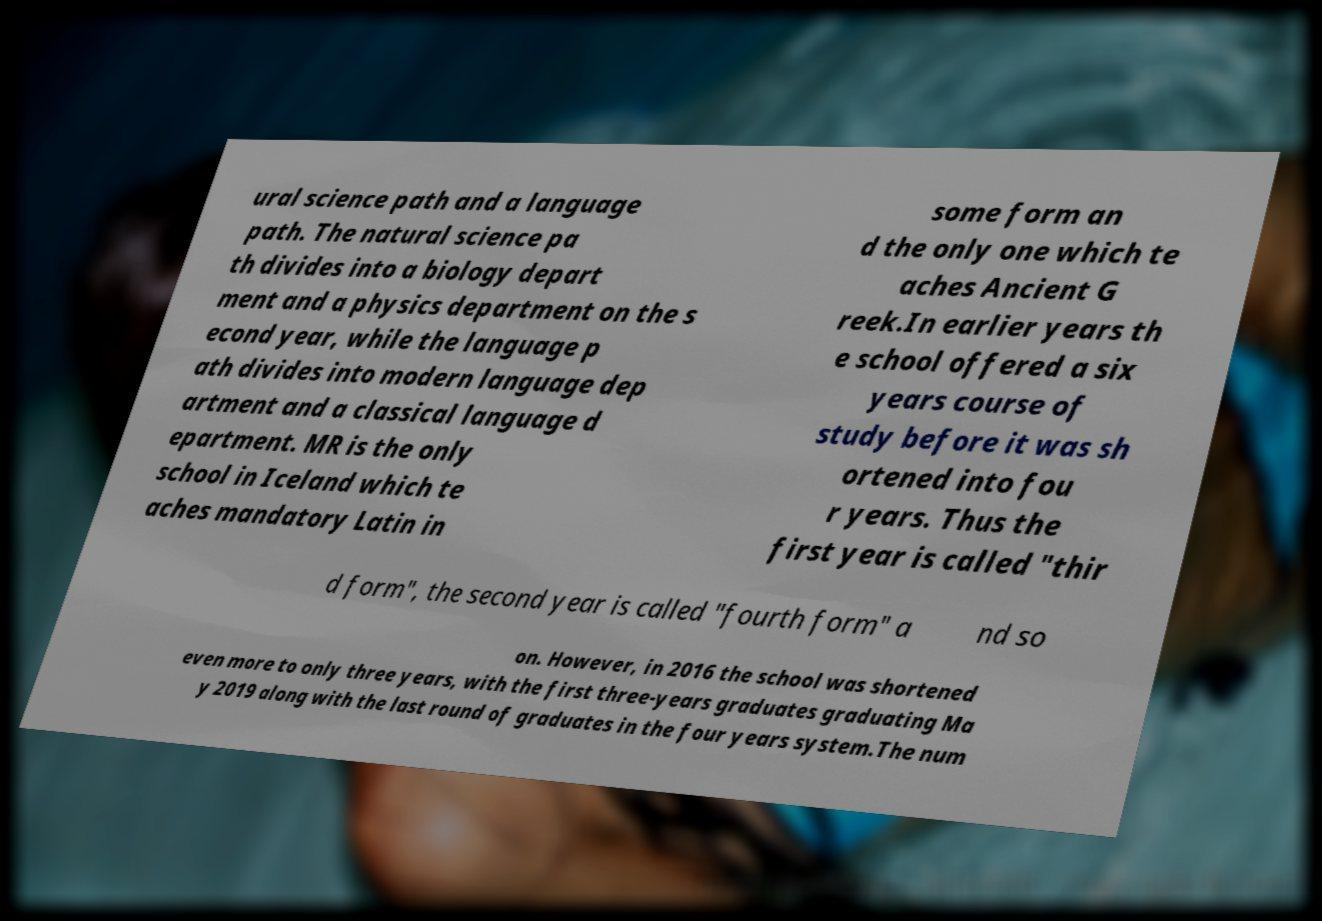Could you extract and type out the text from this image? ural science path and a language path. The natural science pa th divides into a biology depart ment and a physics department on the s econd year, while the language p ath divides into modern language dep artment and a classical language d epartment. MR is the only school in Iceland which te aches mandatory Latin in some form an d the only one which te aches Ancient G reek.In earlier years th e school offered a six years course of study before it was sh ortened into fou r years. Thus the first year is called "thir d form", the second year is called "fourth form" a nd so on. However, in 2016 the school was shortened even more to only three years, with the first three-years graduates graduating Ma y 2019 along with the last round of graduates in the four years system.The num 